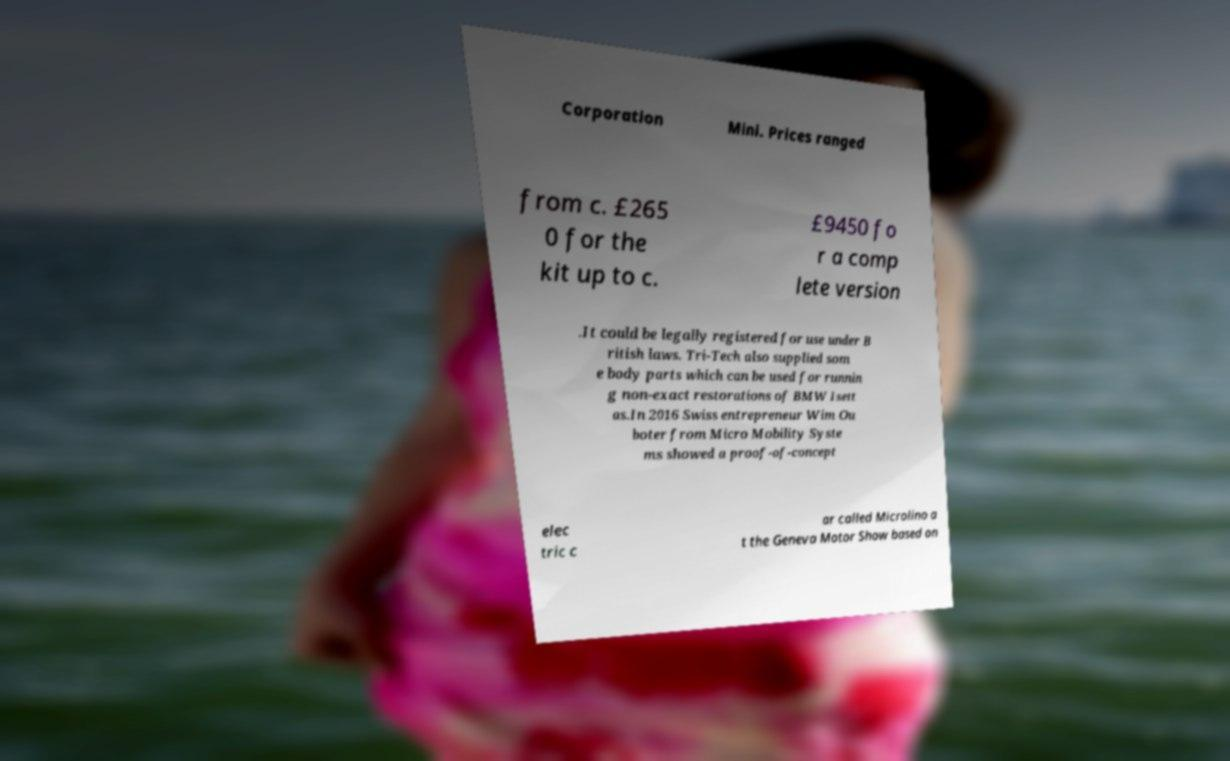Please read and relay the text visible in this image. What does it say? Corporation Mini. Prices ranged from c. £265 0 for the kit up to c. £9450 fo r a comp lete version .It could be legally registered for use under B ritish laws. Tri-Tech also supplied som e body parts which can be used for runnin g non-exact restorations of BMW Isett as.In 2016 Swiss entrepreneur Wim Ou boter from Micro Mobility Syste ms showed a proof-of-concept elec tric c ar called Microlino a t the Geneva Motor Show based on 